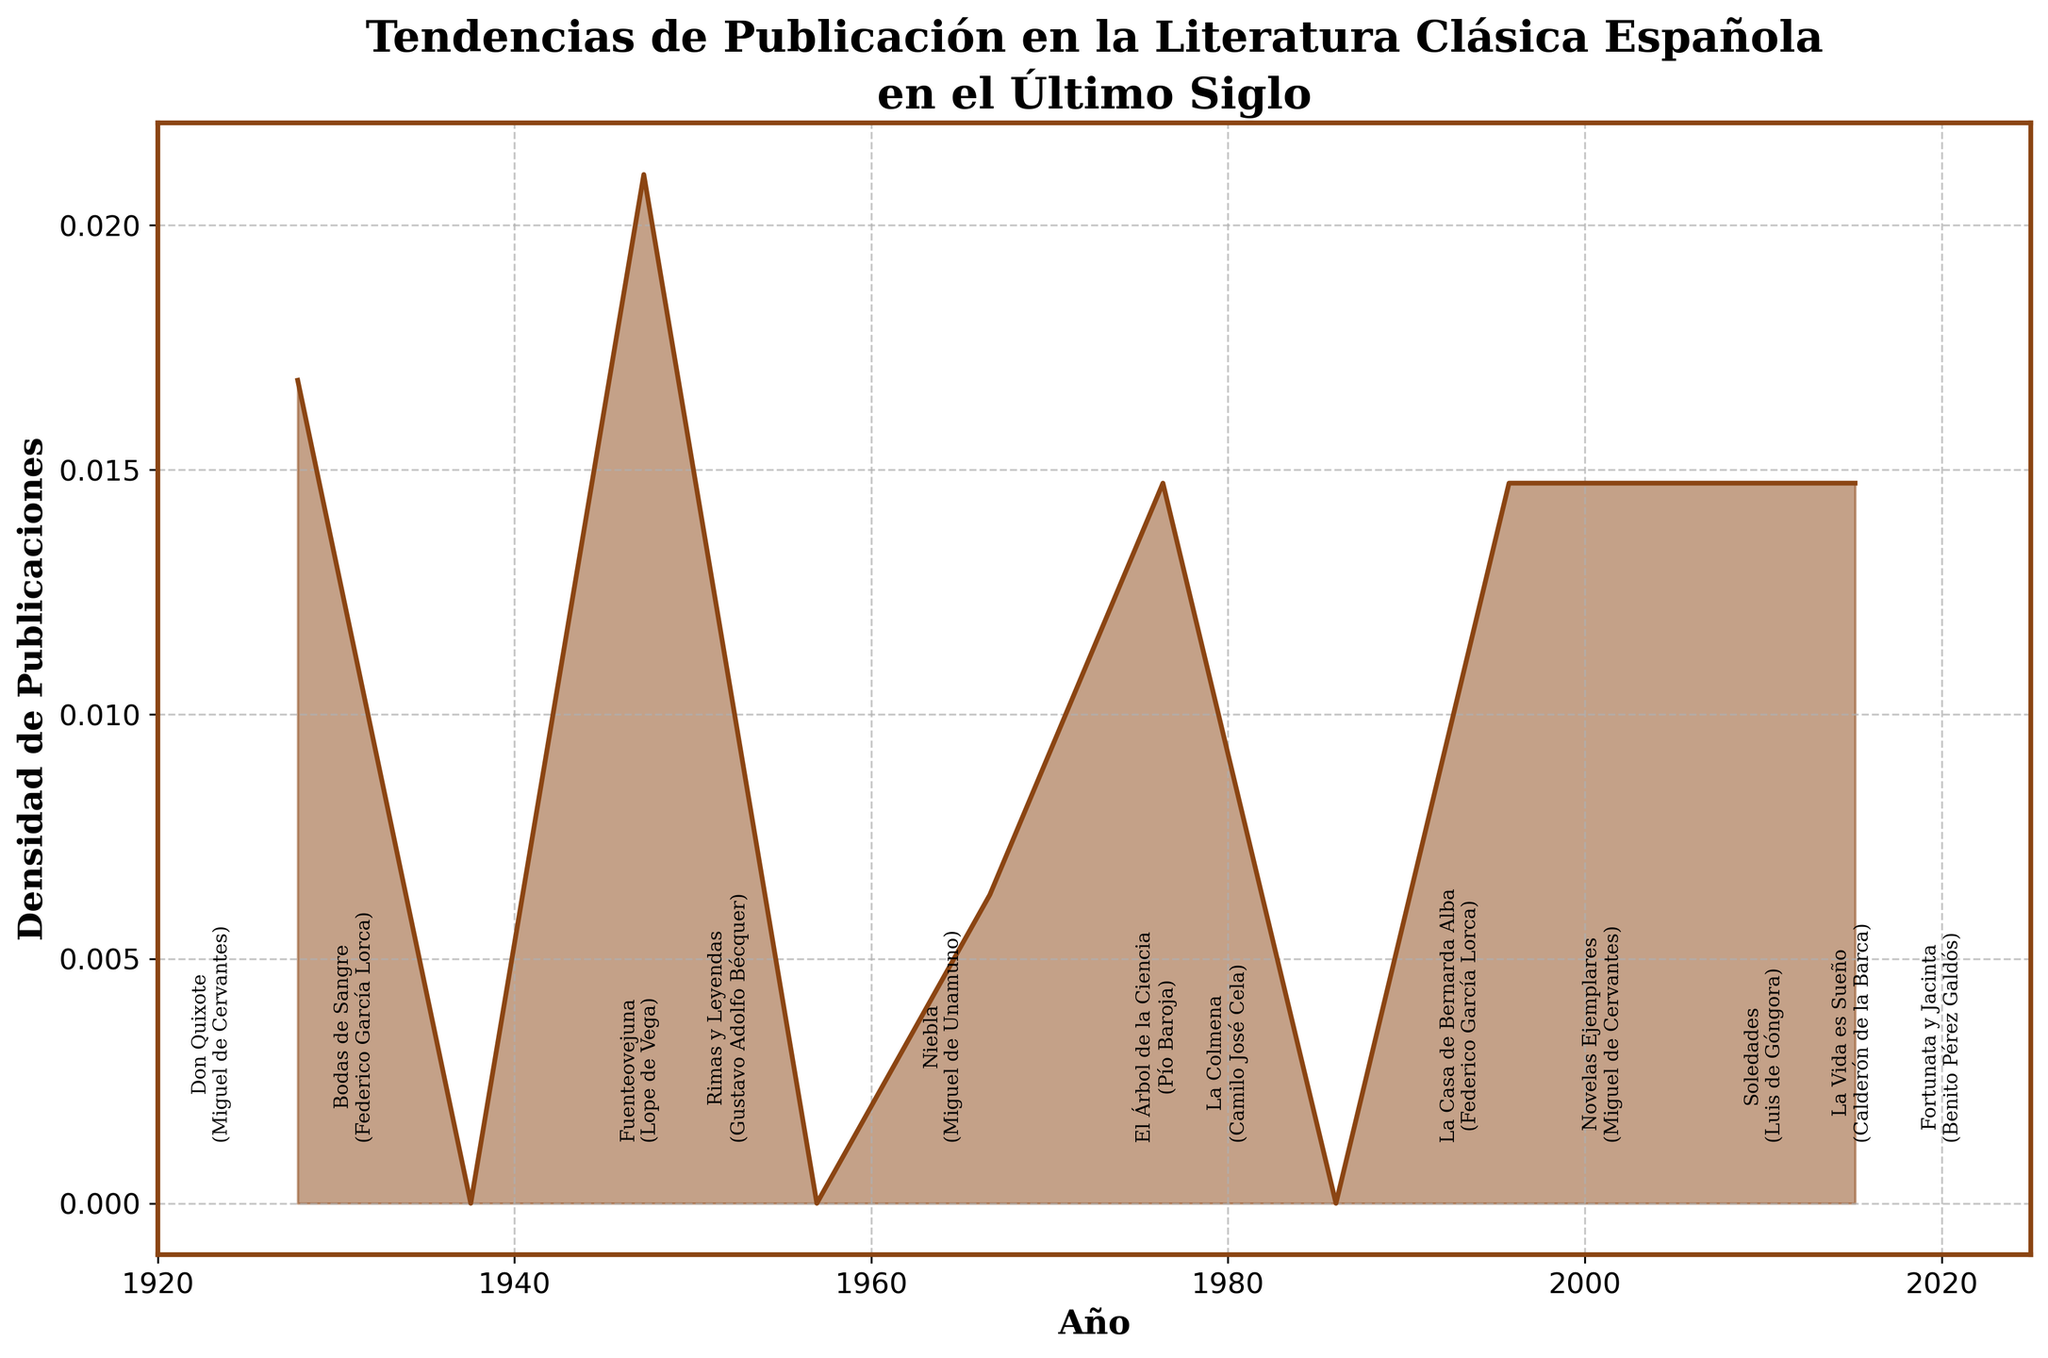What is the title of the figure? The title can be found at the top of the figure and it is meant to describe what the figure is about.
Answer: Tendencias de Publicación en la Literatura Clásica Española en el Último Siglo Which author has the highest number of publications in a single year? By looking at the annotations on the figure, we can see the publications by different authors. Federico García Lorca in 1993 with "La Casa de Bernarda Alba" has the highest number of 7 publications.
Answer: Federico García Lorca Between which years are most of the publications densely packed as suggested by the density plot? Observing the highest peaks in the density plot allows us to determine where publications are most densely packed.
Answer: 1920-1930 and 1980-2000 What is the y-axis representing in this density plot? The y-axis label at the left side of the plot shows what it represents.
Answer: Densidad de Publicaciones How many books were published by Miguel de Cervantes, according to the plot annotations? The annotations for each book by Miguel de Cervantes show "Don Quixote" with 3 in 1923 and "Novelas Ejemplares" with 3 in 2001. Adding these gives 3 + 3 = 6.
Answer: 6 Which decade shows a noticeable decrease in publication density after a peak? Comparing the heights of the density peaks helps us identify a decrease after a peak. The highest peak in the 1990s is followed by a decrease in the 2000s.
Answer: 2000-2010 How do the number of publications of Lope de Vega in 1947 compare to those of Gustavo Adolfo Bécquer in 1952? We compare the numbers provided in the annotations for 1947 and 1952; 6 for Lope de Vega and 4 for Gustavo Adolfo Bécquer.
Answer: Lope de Vega has more publications What is the general trend in the number of publications over the 20th century according to the density plot? Looking at the overall shape of the density plot, we notice the trend of the density of publications rising and falling across the century.
Answer: Increase until 1950s, then fluctuates 